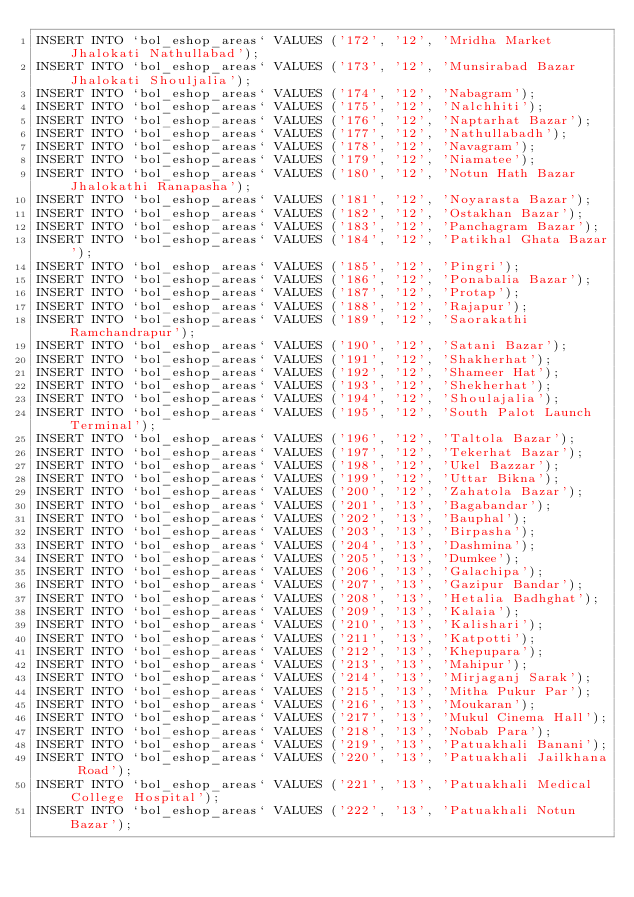Convert code to text. <code><loc_0><loc_0><loc_500><loc_500><_SQL_>INSERT INTO `bol_eshop_areas` VALUES ('172', '12', 'Mridha Market Jhalokati Nathullabad');
INSERT INTO `bol_eshop_areas` VALUES ('173', '12', 'Munsirabad Bazar Jhalokati Shouljalia');
INSERT INTO `bol_eshop_areas` VALUES ('174', '12', 'Nabagram');
INSERT INTO `bol_eshop_areas` VALUES ('175', '12', 'Nalchhiti');
INSERT INTO `bol_eshop_areas` VALUES ('176', '12', 'Naptarhat Bazar');
INSERT INTO `bol_eshop_areas` VALUES ('177', '12', 'Nathullabadh');
INSERT INTO `bol_eshop_areas` VALUES ('178', '12', 'Navagram');
INSERT INTO `bol_eshop_areas` VALUES ('179', '12', 'Niamatee');
INSERT INTO `bol_eshop_areas` VALUES ('180', '12', 'Notun Hath Bazar Jhalokathi Ranapasha');
INSERT INTO `bol_eshop_areas` VALUES ('181', '12', 'Noyarasta Bazar');
INSERT INTO `bol_eshop_areas` VALUES ('182', '12', 'Ostakhan Bazar');
INSERT INTO `bol_eshop_areas` VALUES ('183', '12', 'Panchagram Bazar');
INSERT INTO `bol_eshop_areas` VALUES ('184', '12', 'Patikhal Ghata Bazar');
INSERT INTO `bol_eshop_areas` VALUES ('185', '12', 'Pingri');
INSERT INTO `bol_eshop_areas` VALUES ('186', '12', 'Ponabalia Bazar');
INSERT INTO `bol_eshop_areas` VALUES ('187', '12', 'Protap');
INSERT INTO `bol_eshop_areas` VALUES ('188', '12', 'Rajapur');
INSERT INTO `bol_eshop_areas` VALUES ('189', '12', 'Saorakathi Ramchandrapur');
INSERT INTO `bol_eshop_areas` VALUES ('190', '12', 'Satani Bazar');
INSERT INTO `bol_eshop_areas` VALUES ('191', '12', 'Shakherhat');
INSERT INTO `bol_eshop_areas` VALUES ('192', '12', 'Shameer Hat');
INSERT INTO `bol_eshop_areas` VALUES ('193', '12', 'Shekherhat');
INSERT INTO `bol_eshop_areas` VALUES ('194', '12', 'Shoulajalia');
INSERT INTO `bol_eshop_areas` VALUES ('195', '12', 'South Palot Launch Terminal');
INSERT INTO `bol_eshop_areas` VALUES ('196', '12', 'Taltola Bazar');
INSERT INTO `bol_eshop_areas` VALUES ('197', '12', 'Tekerhat Bazar');
INSERT INTO `bol_eshop_areas` VALUES ('198', '12', 'Ukel Bazzar');
INSERT INTO `bol_eshop_areas` VALUES ('199', '12', 'Uttar Bikna');
INSERT INTO `bol_eshop_areas` VALUES ('200', '12', 'Zahatola Bazar');
INSERT INTO `bol_eshop_areas` VALUES ('201', '13', 'Bagabandar');
INSERT INTO `bol_eshop_areas` VALUES ('202', '13', 'Bauphal');
INSERT INTO `bol_eshop_areas` VALUES ('203', '13', 'Birpasha');
INSERT INTO `bol_eshop_areas` VALUES ('204', '13', 'Dashmina');
INSERT INTO `bol_eshop_areas` VALUES ('205', '13', 'Dumkee');
INSERT INTO `bol_eshop_areas` VALUES ('206', '13', 'Galachipa');
INSERT INTO `bol_eshop_areas` VALUES ('207', '13', 'Gazipur Bandar');
INSERT INTO `bol_eshop_areas` VALUES ('208', '13', 'Hetalia Badhghat');
INSERT INTO `bol_eshop_areas` VALUES ('209', '13', 'Kalaia');
INSERT INTO `bol_eshop_areas` VALUES ('210', '13', 'Kalishari');
INSERT INTO `bol_eshop_areas` VALUES ('211', '13', 'Katpotti');
INSERT INTO `bol_eshop_areas` VALUES ('212', '13', 'Khepupara');
INSERT INTO `bol_eshop_areas` VALUES ('213', '13', 'Mahipur');
INSERT INTO `bol_eshop_areas` VALUES ('214', '13', 'Mirjaganj Sarak');
INSERT INTO `bol_eshop_areas` VALUES ('215', '13', 'Mitha Pukur Par');
INSERT INTO `bol_eshop_areas` VALUES ('216', '13', 'Moukaran');
INSERT INTO `bol_eshop_areas` VALUES ('217', '13', 'Mukul Cinema Hall');
INSERT INTO `bol_eshop_areas` VALUES ('218', '13', 'Nobab Para');
INSERT INTO `bol_eshop_areas` VALUES ('219', '13', 'Patuakhali Banani');
INSERT INTO `bol_eshop_areas` VALUES ('220', '13', 'Patuakhali Jailkhana Road');
INSERT INTO `bol_eshop_areas` VALUES ('221', '13', 'Patuakhali Medical College Hospital');
INSERT INTO `bol_eshop_areas` VALUES ('222', '13', 'Patuakhali Notun Bazar');</code> 